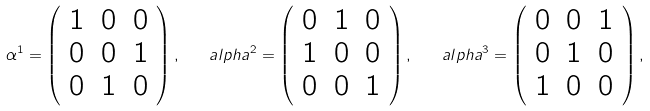Convert formula to latex. <formula><loc_0><loc_0><loc_500><loc_500>\alpha ^ { 1 } = \left ( \begin{array} { c c c } 1 & 0 & 0 \\ 0 & 0 & 1 \\ 0 & 1 & 0 \end{array} \right ) , \quad a l p h a ^ { 2 } = \left ( \begin{array} { c c c } 0 & 1 & 0 \\ 1 & 0 & 0 \\ 0 & 0 & 1 \end{array} \right ) , \quad a l p h a ^ { 3 } = \left ( \begin{array} { c c c } 0 & 0 & 1 \\ 0 & 1 & 0 \\ 1 & 0 & 0 \end{array} \right ) ,</formula> 